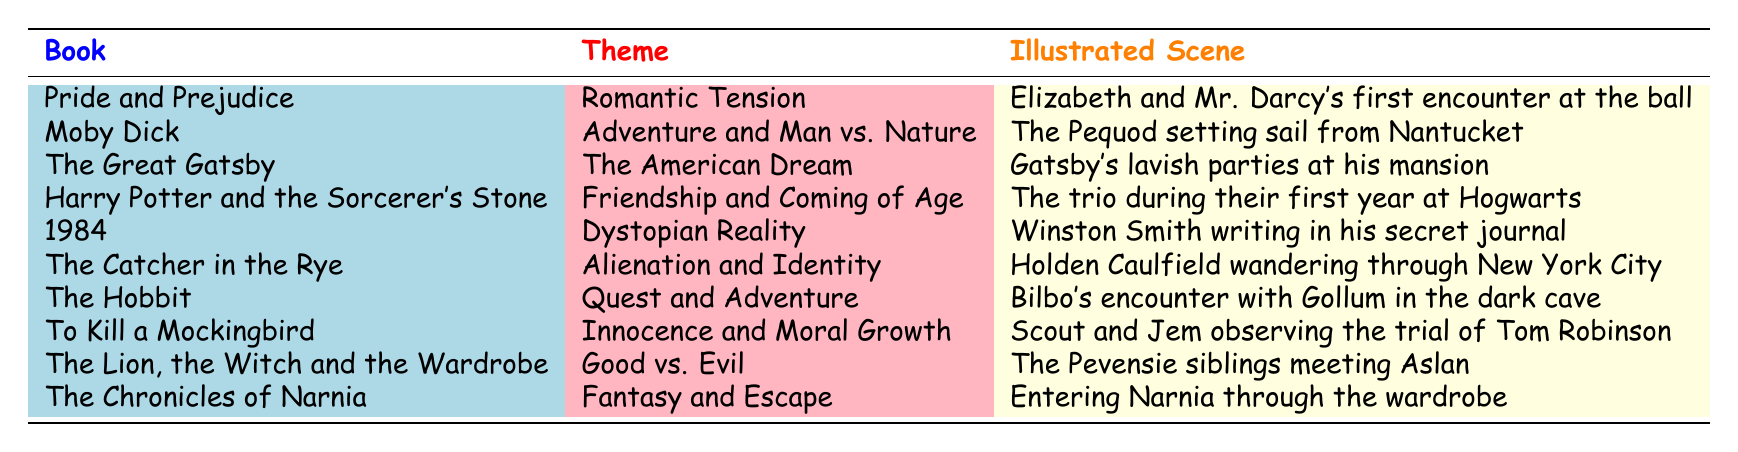What book is associated with the theme of "Dystopian Reality"? By looking at the table, we can see that the book associated with the theme "Dystopian Reality" is "1984".
Answer: 1984 Which illustrated scene is related to the theme "Quest and Adventure"? The theme "Quest and Adventure" is related to the illustrated scene of "Bilbo's encounter with Gollum in the dark cave" from "The Hobbit".
Answer: Bilbo's encounter with Gollum in the dark cave How many books have the theme "Friendship and Coming of Age"? There is only one book listed under the theme "Friendship and Coming of Age": "Harry Potter and the Sorcerer's Stone". Therefore, the count is 1.
Answer: 1 Is "The Great Gatsby" associated with the theme of "The American Dream"? The table clearly states that "The Great Gatsby" is indeed associated with the theme of "The American Dream".
Answer: Yes Which books feature themes related to morality? The books that feature themes related to morality are "To Kill a Mockingbird" (Innocence and Moral Growth) and "1984" (Dystopian Reality). We see two themes touch on morality in the context of the books’ plots.
Answer: To Kill a Mockingbird, 1984 What is the most common theme among the books listed? To determine the most common theme, we look for repetitions. Each theme appears only once in this dataset, indicating there is no theme that is most common.
Answer: None How many themes are represented by fantasy elements in the table? The themes associated with fantasy elements are "Fantasy and Escape" and "Good vs. Evil", which appear in "The Chronicles of Narnia" and "The Lion, the Witch and the Wardrobe", respectively. Therefore, there are 2 themes related to fantasy elements.
Answer: 2 Which illustrated scene involves the concept of "Good vs. Evil"? The illustrated scene that involves the theme "Good vs. Evil" is "The Pevensie siblings meeting Aslan" from "The Lion, the Witch and the Wardrobe".
Answer: The Pevensie siblings meeting Aslan Which book depicts the theme of "Alienation and Identity"? The table shows that the theme "Alienation and Identity" is depicted by "The Catcher in the Rye".
Answer: The Catcher in the Rye 